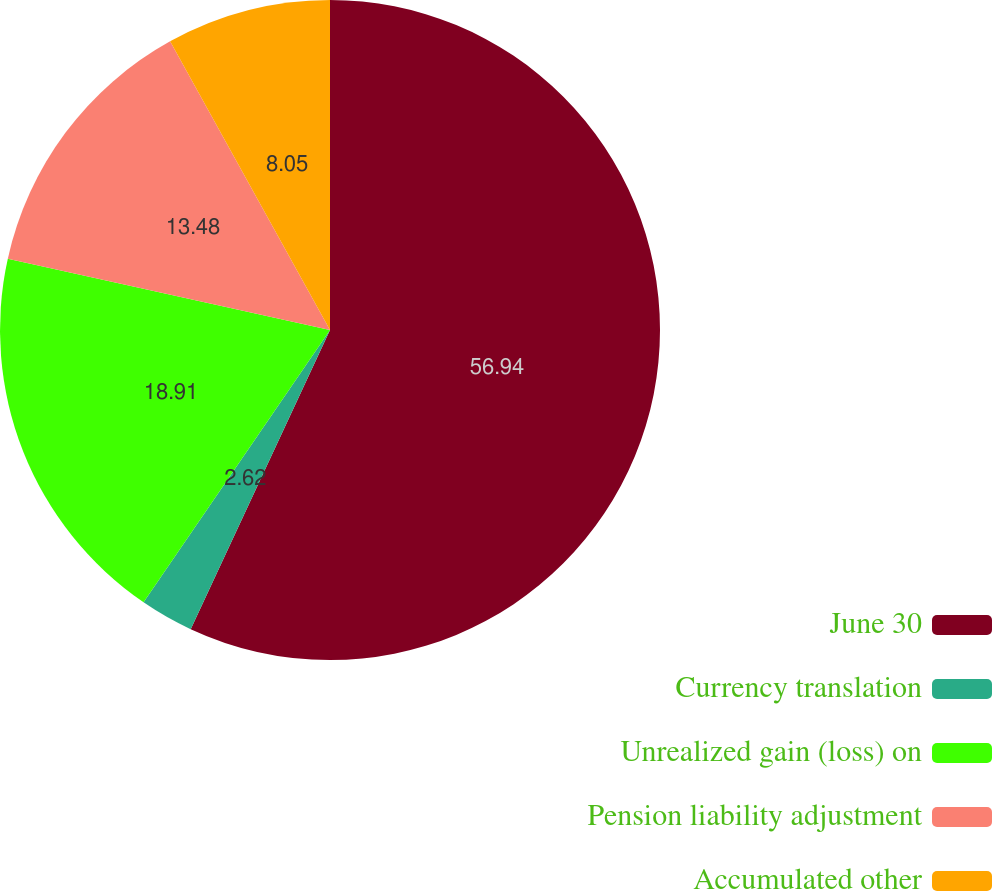Convert chart. <chart><loc_0><loc_0><loc_500><loc_500><pie_chart><fcel>June 30<fcel>Currency translation<fcel>Unrealized gain (loss) on<fcel>Pension liability adjustment<fcel>Accumulated other<nl><fcel>56.93%<fcel>2.62%<fcel>18.91%<fcel>13.48%<fcel>8.05%<nl></chart> 